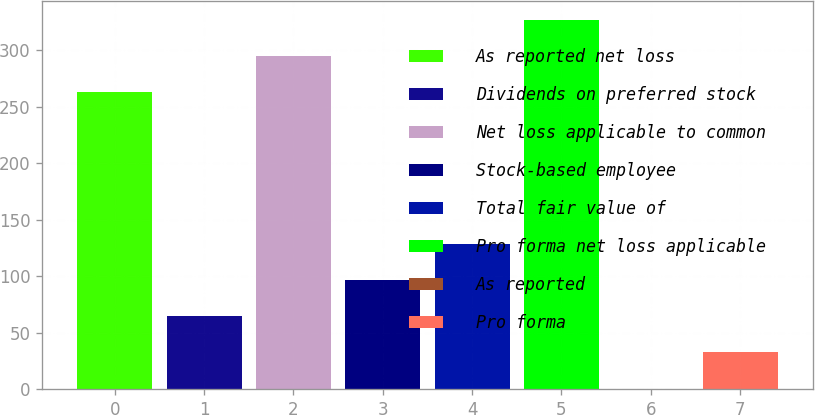Convert chart to OTSL. <chart><loc_0><loc_0><loc_500><loc_500><bar_chart><fcel>As reported net loss<fcel>Dividends on preferred stock<fcel>Net loss applicable to common<fcel>Stock-based employee<fcel>Total fair value of<fcel>Pro forma net loss applicable<fcel>As reported<fcel>Pro forma<nl><fcel>262.9<fcel>64.86<fcel>294.99<fcel>96.95<fcel>129.04<fcel>327.08<fcel>0.68<fcel>32.77<nl></chart> 